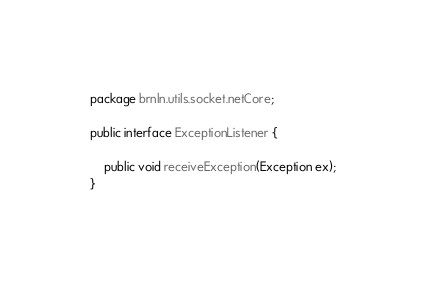<code> <loc_0><loc_0><loc_500><loc_500><_Java_>package brnln.utils.socket.netCore;

public interface ExceptionListener {

    public void receiveException(Exception ex);
}
</code> 